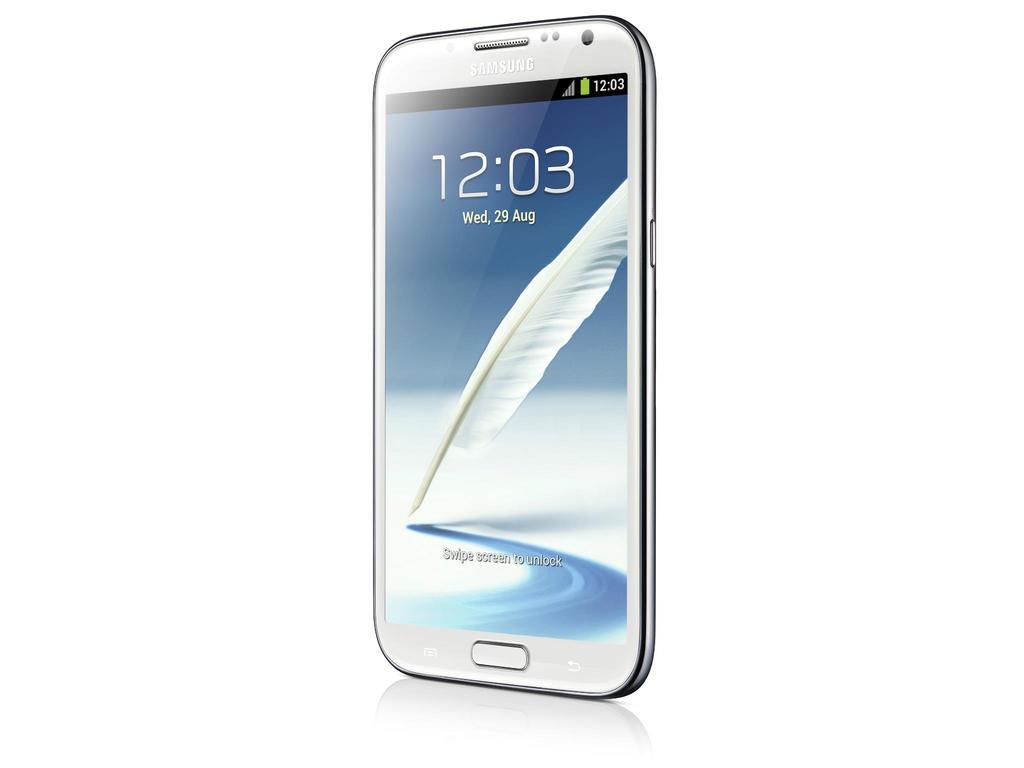What brand is the phone?
Provide a short and direct response. Samsung. What time is it?
Your response must be concise. 12:03. 